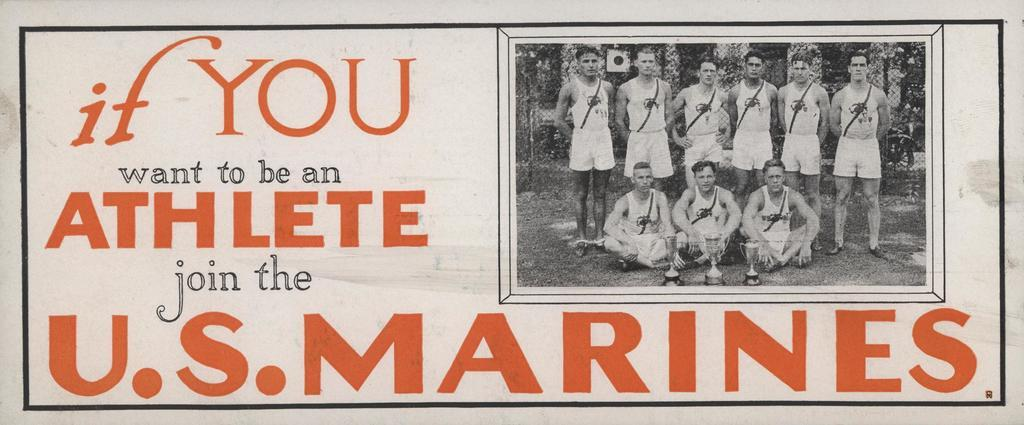<image>
Provide a brief description of the given image. a black and white photo of a sports team advertising for the US marines 